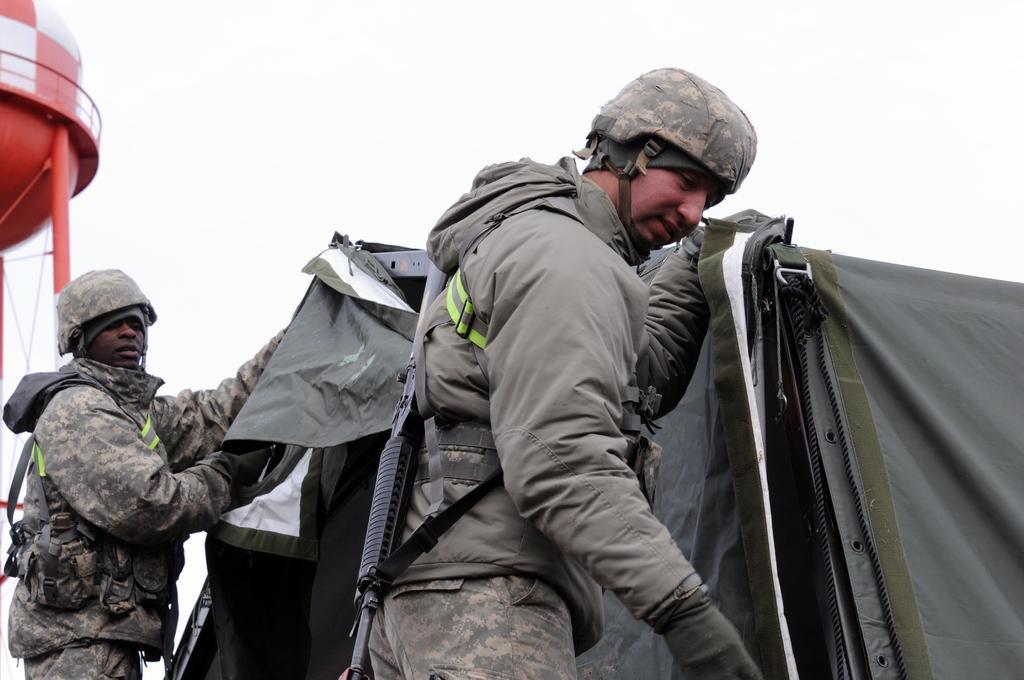Could you give a brief overview of what you see in this image? In this image I can see two persons standing. The person in front wearing brown jacket, background I can see a tent in brown color and sky in white color. 